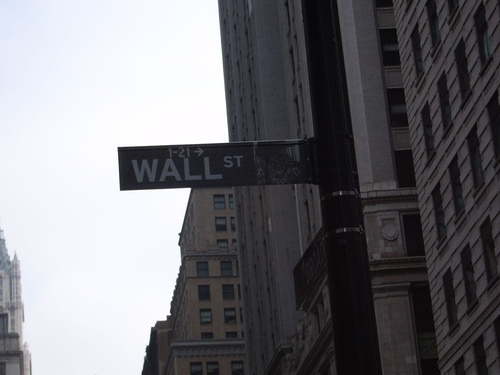Describe the objects in this image and their specific colors. I can see various objects in this image with different colors. 